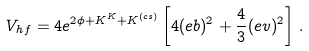Convert formula to latex. <formula><loc_0><loc_0><loc_500><loc_500>V _ { h f } = 4 e ^ { 2 \phi + K ^ { K } + K ^ { ( c s ) } } \left [ 4 ( e b ) ^ { 2 } + \frac { 4 } { 3 } ( e v ) ^ { 2 } \right ] \, .</formula> 